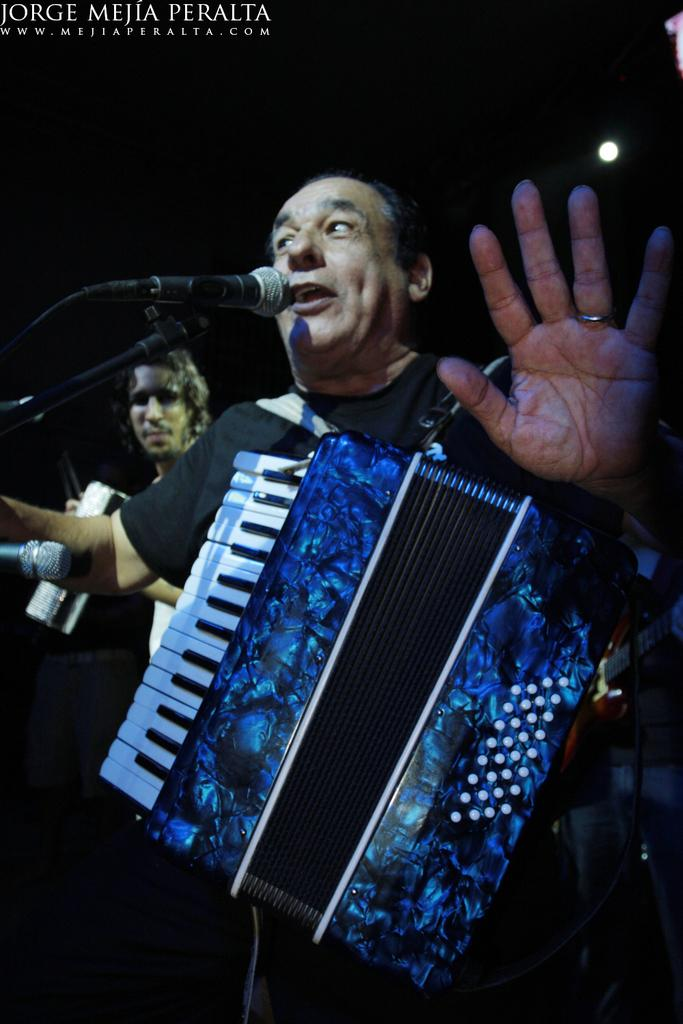What is the man in the image doing? The man is standing near a mic in the image. What instrument is the man wearing? A: The man is wearing a saxophone. Can you describe the other person in the image? There is another person in the background of the image. What can be seen at the top of the image? There is light visible at the top of the image. What type of lunch is being served in the image? There is no lunch visible in the image. What arithmetic problem is being solved by the man in the image? The man in the image is not solving any arithmetic problem; he is wearing a saxophone and standing near a mic. 